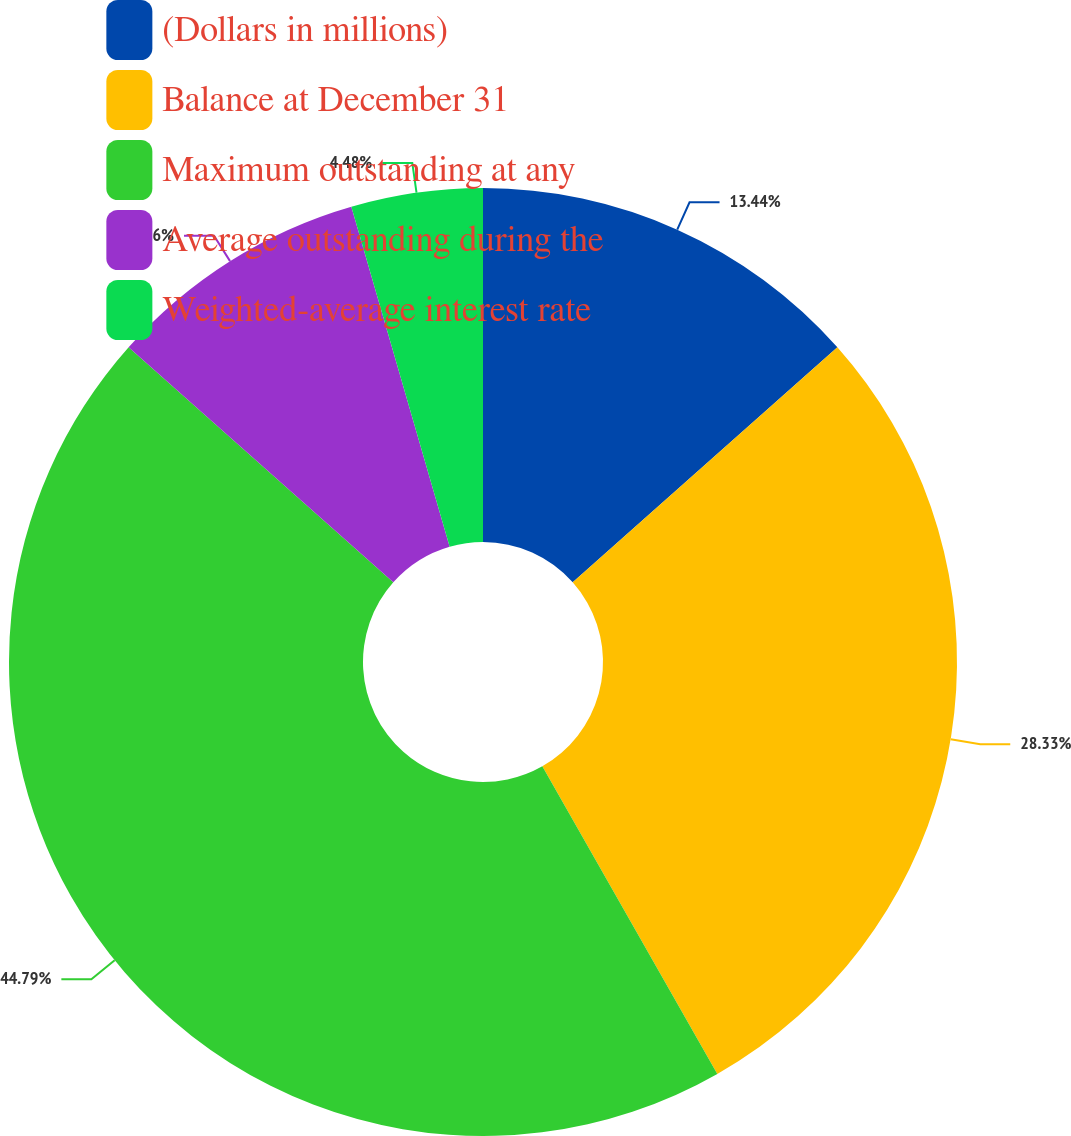Convert chart to OTSL. <chart><loc_0><loc_0><loc_500><loc_500><pie_chart><fcel>(Dollars in millions)<fcel>Balance at December 31<fcel>Maximum outstanding at any<fcel>Average outstanding during the<fcel>Weighted-average interest rate<nl><fcel>13.44%<fcel>28.33%<fcel>44.79%<fcel>8.96%<fcel>4.48%<nl></chart> 